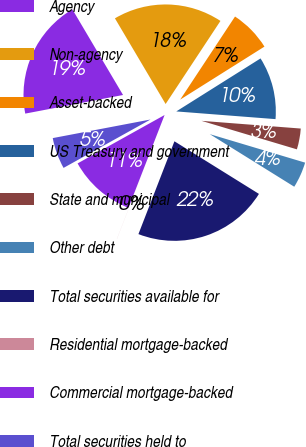Convert chart. <chart><loc_0><loc_0><loc_500><loc_500><pie_chart><fcel>Agency<fcel>Non-agency<fcel>Asset-backed<fcel>US Treasury and government<fcel>State and municipal<fcel>Other debt<fcel>Total securities available for<fcel>Residential mortgage-backed<fcel>Commercial mortgage-backed<fcel>Total securities held to<nl><fcel>19.49%<fcel>17.79%<fcel>6.78%<fcel>10.17%<fcel>3.39%<fcel>4.24%<fcel>22.03%<fcel>0.01%<fcel>11.02%<fcel>5.09%<nl></chart> 